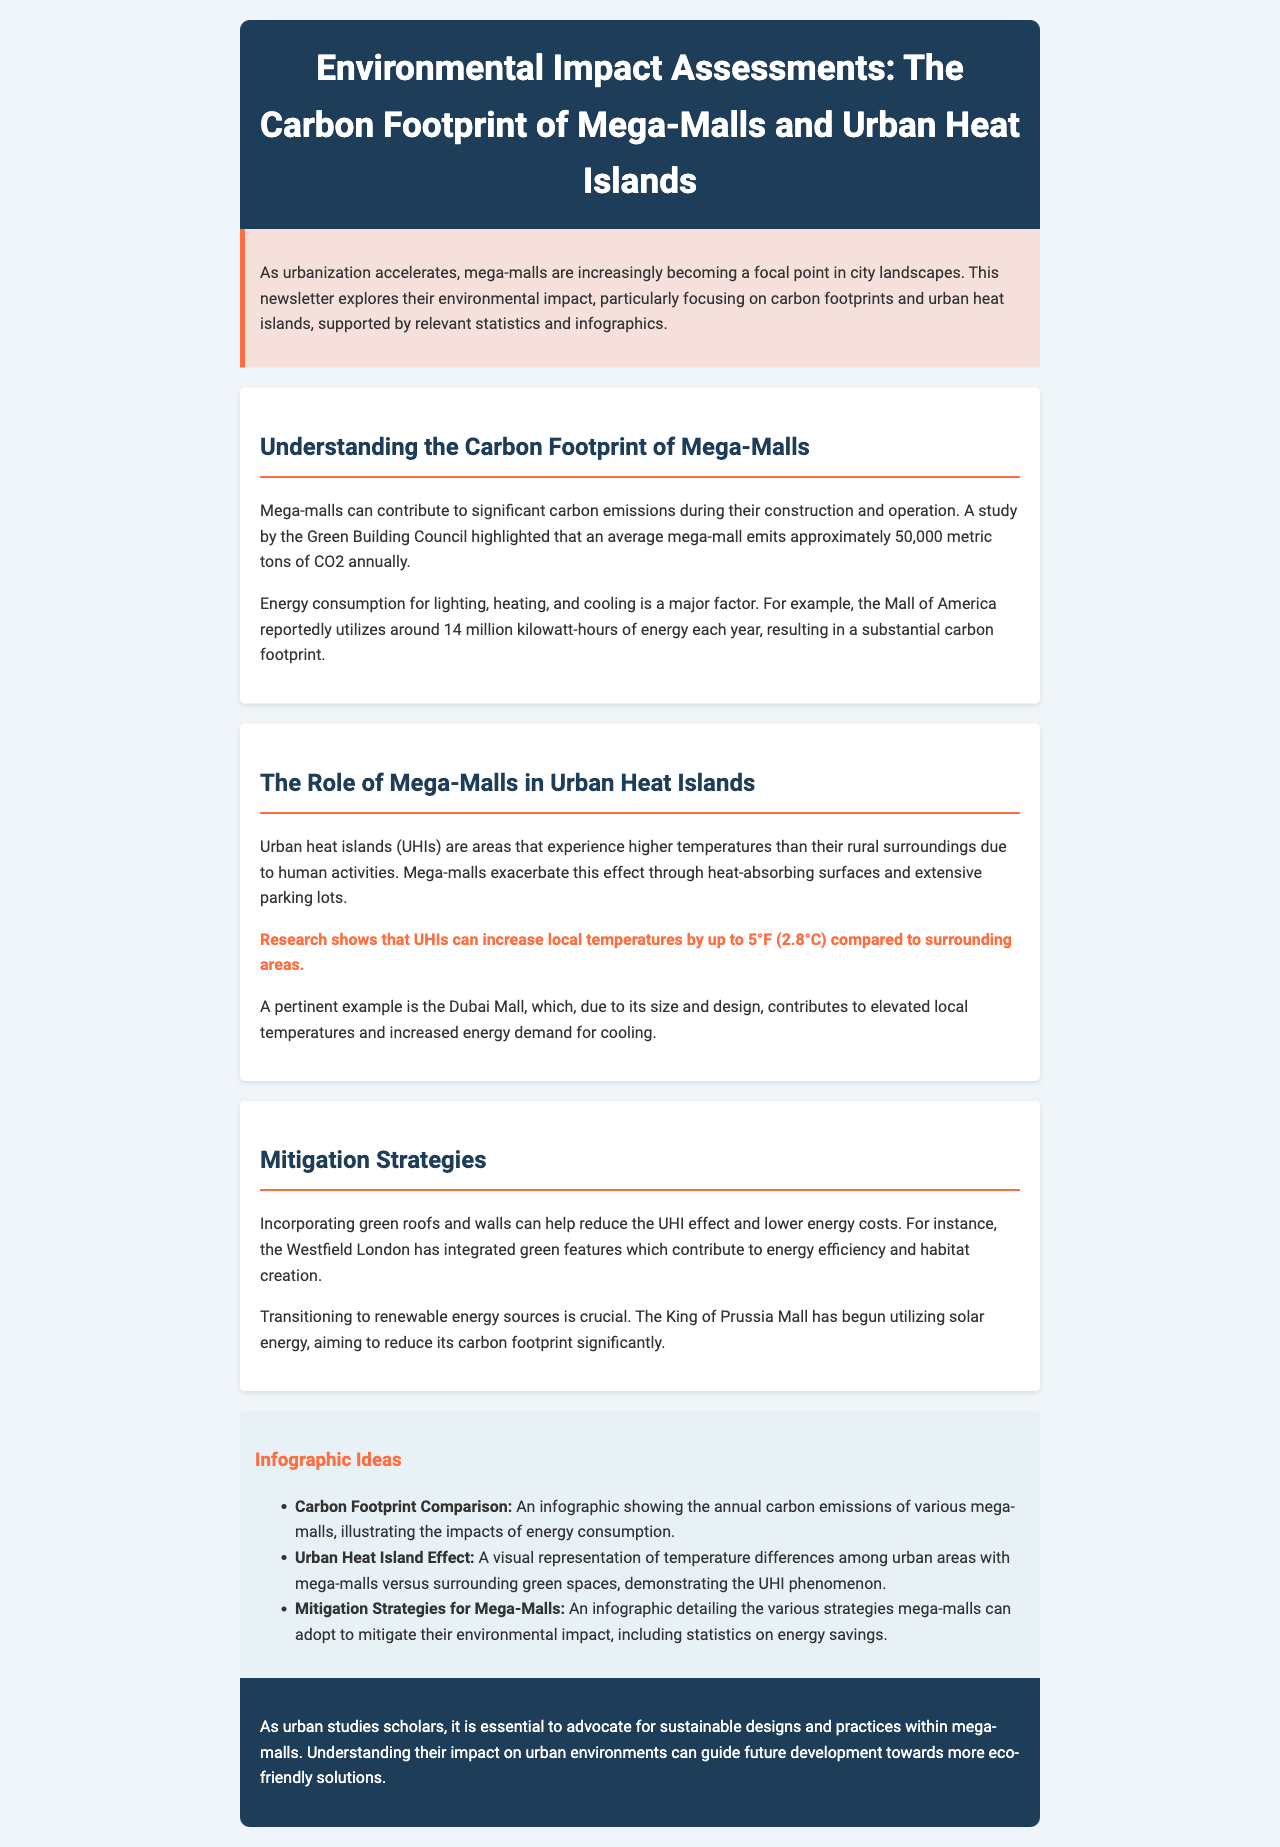What is the average annual CO2 emission of a mega-mall? The document states that an average mega-mall emits approximately 50,000 metric tons of CO2 annually.
Answer: 50,000 metric tons How many kilowatt-hours of energy does the Mall of America use each year? The document mentions that the Mall of America reportedly utilizes around 14 million kilowatt-hours of energy each year.
Answer: 14 million kilowatt-hours What temperature increase can urban heat islands cause? The document states that research shows that UHIs can increase local temperatures by up to 5°F (2.8°C) compared to surrounding areas.
Answer: 5°F (2.8°C) Which mall has begun utilizing solar energy for sustainability? According to the document, the King of Prussia Mall has begun utilizing solar energy aiming to reduce its carbon footprint significantly.
Answer: King of Prussia Mall What is one mitigation strategy mentioned in the document? The document discusses incorporating green roofs and walls as a strategy to help reduce the UHI effect.
Answer: Green roofs and walls Which mall integrated green features for energy efficiency? The document notes that the Westfield London has integrated green features contributing to energy efficiency.
Answer: Westfield London What is the primary focus of the newsletter? The document emphasizes exploring the environmental impact of mega-malls, particularly regarding carbon footprints and urban heat islands.
Answer: Environmental impact of mega-malls What type of infographic is suggested for displaying carbon emissions? The document suggests a "Carbon Footprint Comparison" infographic showing the annual carbon emissions of various mega-malls.
Answer: Carbon Footprint Comparison What is the background color of the conclusion section? The document specifies that the conclusion section has a background color of #1e3d59.
Answer: #1e3d59 